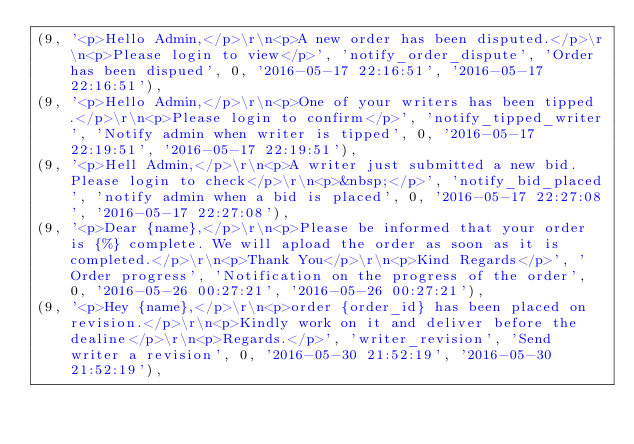<code> <loc_0><loc_0><loc_500><loc_500><_SQL_>(9, '<p>Hello Admin,</p>\r\n<p>A new order has been disputed.</p>\r\n<p>Please login to view</p>', 'notify_order_dispute', 'Order has been dispued', 0, '2016-05-17 22:16:51', '2016-05-17 22:16:51'),
(9, '<p>Hello Admin,</p>\r\n<p>One of your writers has been tipped.</p>\r\n<p>Please login to confirm</p>', 'notify_tipped_writer', 'Notify admin when writer is tipped', 0, '2016-05-17 22:19:51', '2016-05-17 22:19:51'),
(9, '<p>Hell Admin,</p>\r\n<p>A writer just submitted a new bid. Please login to check</p>\r\n<p>&nbsp;</p>', 'notify_bid_placed', 'notify admin when a bid is placed', 0, '2016-05-17 22:27:08', '2016-05-17 22:27:08'),
(9, '<p>Dear {name},</p>\r\n<p>Please be informed that your order is {%} complete. We will apload the order as soon as it is completed.</p>\r\n<p>Thank You</p>\r\n<p>Kind Regards</p>', 'Order progress', 'Notification on the progress of the order', 0, '2016-05-26 00:27:21', '2016-05-26 00:27:21'),
(9, '<p>Hey {name},</p>\r\n<p>order {order_id} has been placed on revision.</p>\r\n<p>Kindly work on it and deliver before the dealine</p>\r\n<p>Regards.</p>', 'writer_revision', 'Send writer a revision', 0, '2016-05-30 21:52:19', '2016-05-30 21:52:19'),</code> 